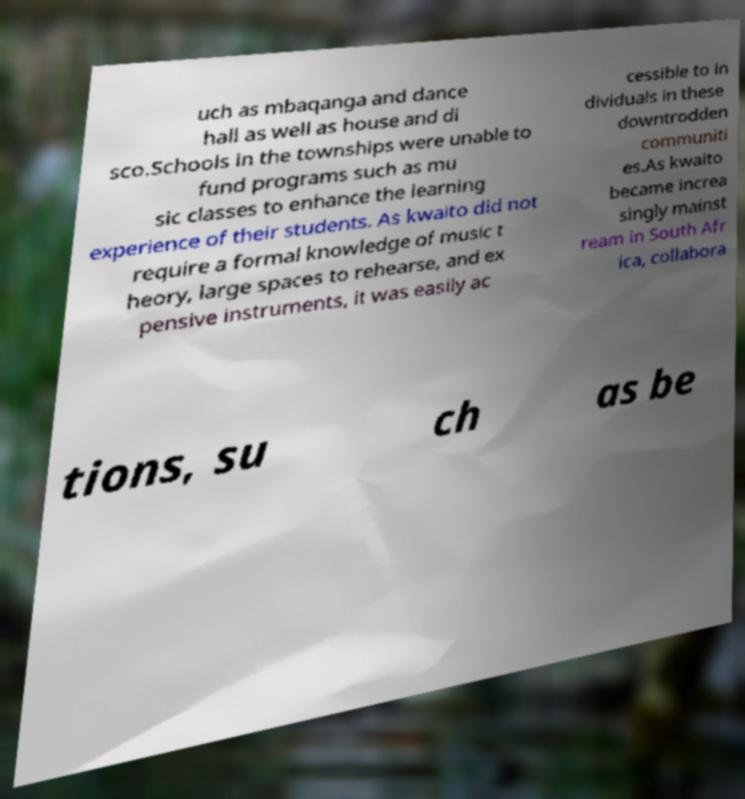There's text embedded in this image that I need extracted. Can you transcribe it verbatim? uch as mbaqanga and dance hall as well as house and di sco.Schools in the townships were unable to fund programs such as mu sic classes to enhance the learning experience of their students. As kwaito did not require a formal knowledge of music t heory, large spaces to rehearse, and ex pensive instruments, it was easily ac cessible to in dividuals in these downtrodden communiti es.As kwaito became increa singly mainst ream in South Afr ica, collabora tions, su ch as be 